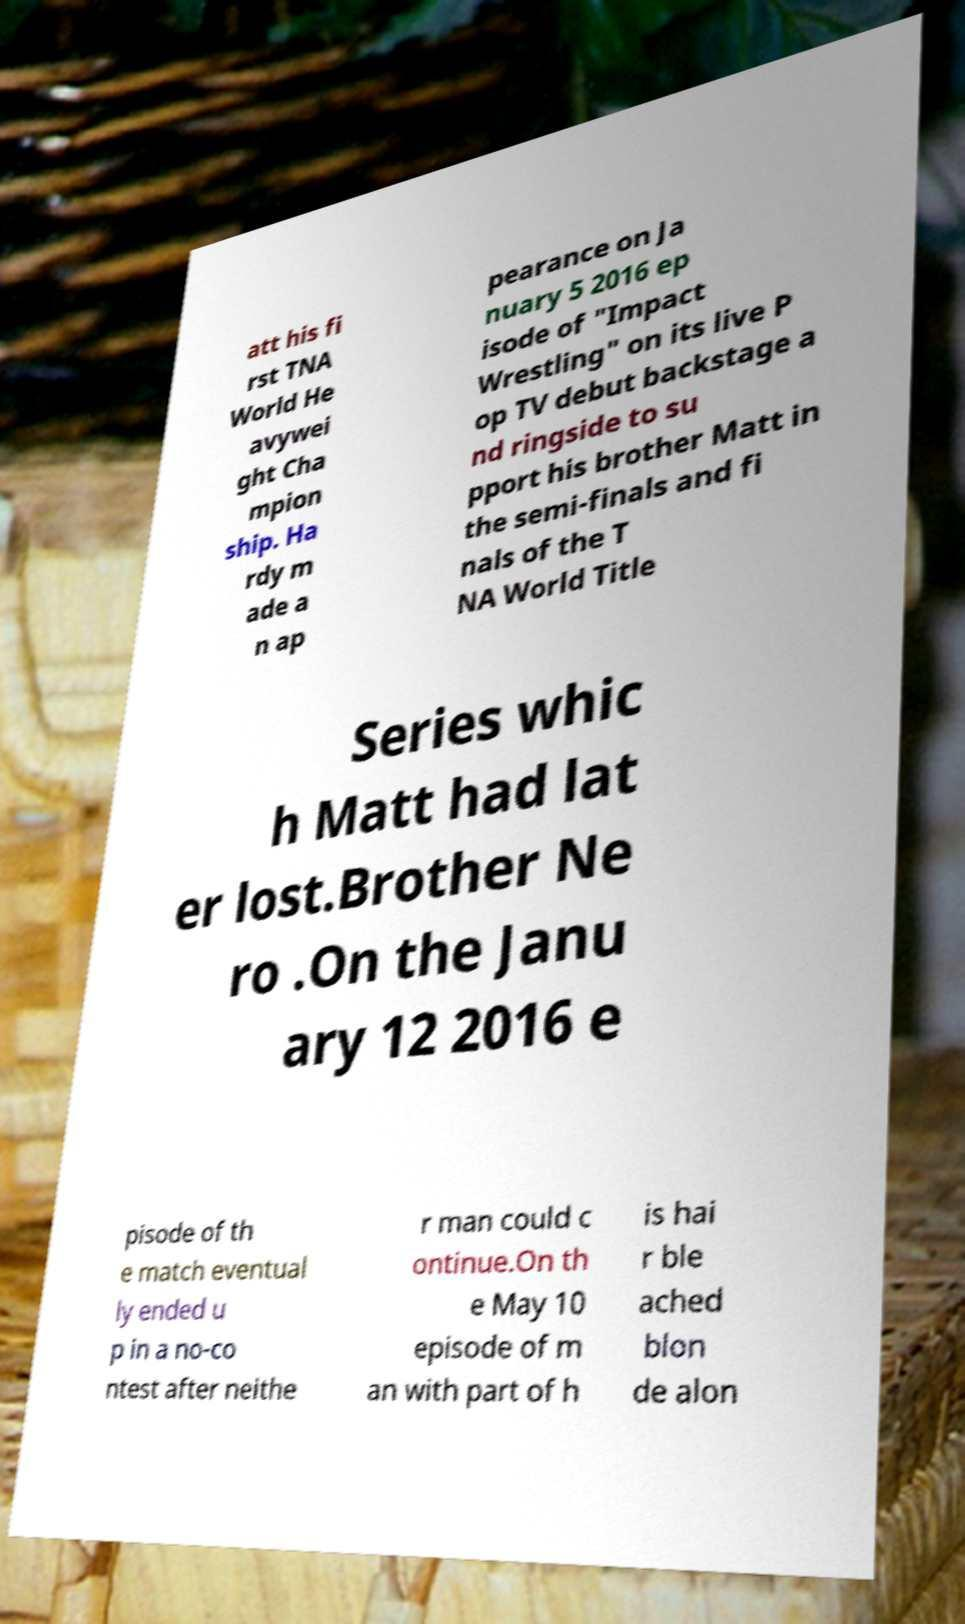Please identify and transcribe the text found in this image. att his fi rst TNA World He avywei ght Cha mpion ship. Ha rdy m ade a n ap pearance on Ja nuary 5 2016 ep isode of "Impact Wrestling" on its live P op TV debut backstage a nd ringside to su pport his brother Matt in the semi-finals and fi nals of the T NA World Title Series whic h Matt had lat er lost.Brother Ne ro .On the Janu ary 12 2016 e pisode of th e match eventual ly ended u p in a no-co ntest after neithe r man could c ontinue.On th e May 10 episode of m an with part of h is hai r ble ached blon de alon 